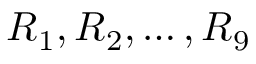Convert formula to latex. <formula><loc_0><loc_0><loc_500><loc_500>R _ { 1 } , R _ { 2 } , \dots , R _ { 9 }</formula> 